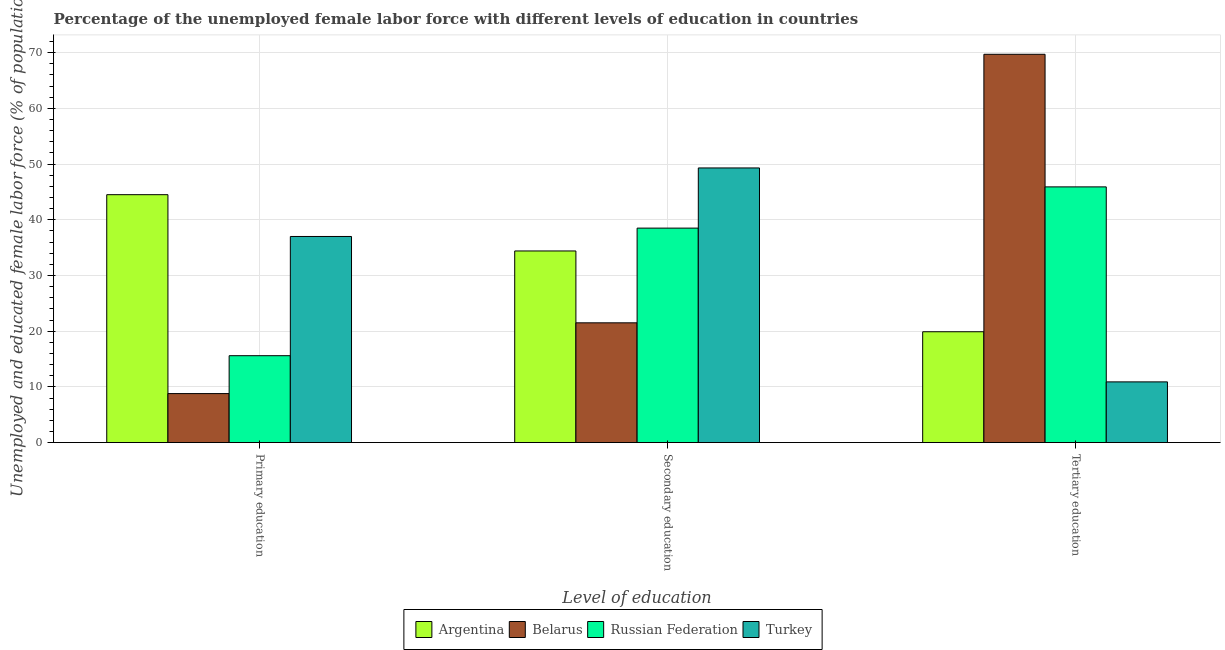What is the label of the 3rd group of bars from the left?
Provide a short and direct response. Tertiary education. What is the percentage of female labor force who received tertiary education in Russian Federation?
Your answer should be very brief. 45.9. Across all countries, what is the maximum percentage of female labor force who received primary education?
Provide a succinct answer. 44.5. Across all countries, what is the minimum percentage of female labor force who received tertiary education?
Your answer should be compact. 10.9. In which country was the percentage of female labor force who received secondary education minimum?
Keep it short and to the point. Belarus. What is the total percentage of female labor force who received primary education in the graph?
Your answer should be compact. 105.9. What is the difference between the percentage of female labor force who received primary education in Turkey and that in Argentina?
Give a very brief answer. -7.5. What is the difference between the percentage of female labor force who received primary education in Turkey and the percentage of female labor force who received secondary education in Argentina?
Make the answer very short. 2.6. What is the average percentage of female labor force who received secondary education per country?
Provide a short and direct response. 35.93. What is the difference between the percentage of female labor force who received primary education and percentage of female labor force who received secondary education in Russian Federation?
Offer a terse response. -22.9. In how many countries, is the percentage of female labor force who received primary education greater than 10 %?
Your response must be concise. 3. What is the ratio of the percentage of female labor force who received primary education in Belarus to that in Russian Federation?
Provide a short and direct response. 0.56. What is the difference between the highest and the second highest percentage of female labor force who received secondary education?
Ensure brevity in your answer.  10.8. What is the difference between the highest and the lowest percentage of female labor force who received primary education?
Make the answer very short. 35.7. Is the sum of the percentage of female labor force who received tertiary education in Turkey and Russian Federation greater than the maximum percentage of female labor force who received primary education across all countries?
Make the answer very short. Yes. What does the 4th bar from the left in Secondary education represents?
Make the answer very short. Turkey. What does the 3rd bar from the right in Primary education represents?
Offer a terse response. Belarus. Is it the case that in every country, the sum of the percentage of female labor force who received primary education and percentage of female labor force who received secondary education is greater than the percentage of female labor force who received tertiary education?
Offer a terse response. No. How many bars are there?
Provide a short and direct response. 12. Are all the bars in the graph horizontal?
Keep it short and to the point. No. What is the difference between two consecutive major ticks on the Y-axis?
Provide a succinct answer. 10. Does the graph contain grids?
Give a very brief answer. Yes. Where does the legend appear in the graph?
Provide a short and direct response. Bottom center. How many legend labels are there?
Give a very brief answer. 4. What is the title of the graph?
Your response must be concise. Percentage of the unemployed female labor force with different levels of education in countries. What is the label or title of the X-axis?
Keep it short and to the point. Level of education. What is the label or title of the Y-axis?
Give a very brief answer. Unemployed and educated female labor force (% of population). What is the Unemployed and educated female labor force (% of population) in Argentina in Primary education?
Your answer should be very brief. 44.5. What is the Unemployed and educated female labor force (% of population) in Belarus in Primary education?
Offer a terse response. 8.8. What is the Unemployed and educated female labor force (% of population) in Russian Federation in Primary education?
Provide a succinct answer. 15.6. What is the Unemployed and educated female labor force (% of population) in Turkey in Primary education?
Your answer should be very brief. 37. What is the Unemployed and educated female labor force (% of population) of Argentina in Secondary education?
Your answer should be compact. 34.4. What is the Unemployed and educated female labor force (% of population) in Belarus in Secondary education?
Keep it short and to the point. 21.5. What is the Unemployed and educated female labor force (% of population) of Russian Federation in Secondary education?
Make the answer very short. 38.5. What is the Unemployed and educated female labor force (% of population) of Turkey in Secondary education?
Your response must be concise. 49.3. What is the Unemployed and educated female labor force (% of population) of Argentina in Tertiary education?
Your answer should be compact. 19.9. What is the Unemployed and educated female labor force (% of population) of Belarus in Tertiary education?
Provide a short and direct response. 69.7. What is the Unemployed and educated female labor force (% of population) in Russian Federation in Tertiary education?
Provide a succinct answer. 45.9. What is the Unemployed and educated female labor force (% of population) in Turkey in Tertiary education?
Offer a terse response. 10.9. Across all Level of education, what is the maximum Unemployed and educated female labor force (% of population) in Argentina?
Your answer should be very brief. 44.5. Across all Level of education, what is the maximum Unemployed and educated female labor force (% of population) of Belarus?
Provide a succinct answer. 69.7. Across all Level of education, what is the maximum Unemployed and educated female labor force (% of population) of Russian Federation?
Give a very brief answer. 45.9. Across all Level of education, what is the maximum Unemployed and educated female labor force (% of population) of Turkey?
Make the answer very short. 49.3. Across all Level of education, what is the minimum Unemployed and educated female labor force (% of population) of Argentina?
Give a very brief answer. 19.9. Across all Level of education, what is the minimum Unemployed and educated female labor force (% of population) of Belarus?
Ensure brevity in your answer.  8.8. Across all Level of education, what is the minimum Unemployed and educated female labor force (% of population) in Russian Federation?
Give a very brief answer. 15.6. Across all Level of education, what is the minimum Unemployed and educated female labor force (% of population) of Turkey?
Provide a succinct answer. 10.9. What is the total Unemployed and educated female labor force (% of population) in Argentina in the graph?
Ensure brevity in your answer.  98.8. What is the total Unemployed and educated female labor force (% of population) in Turkey in the graph?
Make the answer very short. 97.2. What is the difference between the Unemployed and educated female labor force (% of population) of Argentina in Primary education and that in Secondary education?
Offer a terse response. 10.1. What is the difference between the Unemployed and educated female labor force (% of population) in Belarus in Primary education and that in Secondary education?
Provide a succinct answer. -12.7. What is the difference between the Unemployed and educated female labor force (% of population) of Russian Federation in Primary education and that in Secondary education?
Give a very brief answer. -22.9. What is the difference between the Unemployed and educated female labor force (% of population) of Argentina in Primary education and that in Tertiary education?
Ensure brevity in your answer.  24.6. What is the difference between the Unemployed and educated female labor force (% of population) of Belarus in Primary education and that in Tertiary education?
Offer a terse response. -60.9. What is the difference between the Unemployed and educated female labor force (% of population) of Russian Federation in Primary education and that in Tertiary education?
Keep it short and to the point. -30.3. What is the difference between the Unemployed and educated female labor force (% of population) in Turkey in Primary education and that in Tertiary education?
Your response must be concise. 26.1. What is the difference between the Unemployed and educated female labor force (% of population) in Belarus in Secondary education and that in Tertiary education?
Provide a succinct answer. -48.2. What is the difference between the Unemployed and educated female labor force (% of population) in Russian Federation in Secondary education and that in Tertiary education?
Offer a very short reply. -7.4. What is the difference between the Unemployed and educated female labor force (% of population) in Turkey in Secondary education and that in Tertiary education?
Offer a very short reply. 38.4. What is the difference between the Unemployed and educated female labor force (% of population) in Argentina in Primary education and the Unemployed and educated female labor force (% of population) in Belarus in Secondary education?
Offer a terse response. 23. What is the difference between the Unemployed and educated female labor force (% of population) of Belarus in Primary education and the Unemployed and educated female labor force (% of population) of Russian Federation in Secondary education?
Make the answer very short. -29.7. What is the difference between the Unemployed and educated female labor force (% of population) of Belarus in Primary education and the Unemployed and educated female labor force (% of population) of Turkey in Secondary education?
Offer a very short reply. -40.5. What is the difference between the Unemployed and educated female labor force (% of population) in Russian Federation in Primary education and the Unemployed and educated female labor force (% of population) in Turkey in Secondary education?
Your response must be concise. -33.7. What is the difference between the Unemployed and educated female labor force (% of population) in Argentina in Primary education and the Unemployed and educated female labor force (% of population) in Belarus in Tertiary education?
Your answer should be very brief. -25.2. What is the difference between the Unemployed and educated female labor force (% of population) in Argentina in Primary education and the Unemployed and educated female labor force (% of population) in Russian Federation in Tertiary education?
Make the answer very short. -1.4. What is the difference between the Unemployed and educated female labor force (% of population) of Argentina in Primary education and the Unemployed and educated female labor force (% of population) of Turkey in Tertiary education?
Make the answer very short. 33.6. What is the difference between the Unemployed and educated female labor force (% of population) in Belarus in Primary education and the Unemployed and educated female labor force (% of population) in Russian Federation in Tertiary education?
Ensure brevity in your answer.  -37.1. What is the difference between the Unemployed and educated female labor force (% of population) of Russian Federation in Primary education and the Unemployed and educated female labor force (% of population) of Turkey in Tertiary education?
Provide a short and direct response. 4.7. What is the difference between the Unemployed and educated female labor force (% of population) of Argentina in Secondary education and the Unemployed and educated female labor force (% of population) of Belarus in Tertiary education?
Offer a terse response. -35.3. What is the difference between the Unemployed and educated female labor force (% of population) in Belarus in Secondary education and the Unemployed and educated female labor force (% of population) in Russian Federation in Tertiary education?
Provide a short and direct response. -24.4. What is the difference between the Unemployed and educated female labor force (% of population) in Russian Federation in Secondary education and the Unemployed and educated female labor force (% of population) in Turkey in Tertiary education?
Offer a terse response. 27.6. What is the average Unemployed and educated female labor force (% of population) of Argentina per Level of education?
Provide a succinct answer. 32.93. What is the average Unemployed and educated female labor force (% of population) in Belarus per Level of education?
Your answer should be compact. 33.33. What is the average Unemployed and educated female labor force (% of population) in Russian Federation per Level of education?
Give a very brief answer. 33.33. What is the average Unemployed and educated female labor force (% of population) in Turkey per Level of education?
Your answer should be very brief. 32.4. What is the difference between the Unemployed and educated female labor force (% of population) of Argentina and Unemployed and educated female labor force (% of population) of Belarus in Primary education?
Give a very brief answer. 35.7. What is the difference between the Unemployed and educated female labor force (% of population) of Argentina and Unemployed and educated female labor force (% of population) of Russian Federation in Primary education?
Provide a short and direct response. 28.9. What is the difference between the Unemployed and educated female labor force (% of population) in Belarus and Unemployed and educated female labor force (% of population) in Russian Federation in Primary education?
Make the answer very short. -6.8. What is the difference between the Unemployed and educated female labor force (% of population) in Belarus and Unemployed and educated female labor force (% of population) in Turkey in Primary education?
Make the answer very short. -28.2. What is the difference between the Unemployed and educated female labor force (% of population) in Russian Federation and Unemployed and educated female labor force (% of population) in Turkey in Primary education?
Ensure brevity in your answer.  -21.4. What is the difference between the Unemployed and educated female labor force (% of population) in Argentina and Unemployed and educated female labor force (% of population) in Russian Federation in Secondary education?
Ensure brevity in your answer.  -4.1. What is the difference between the Unemployed and educated female labor force (% of population) in Argentina and Unemployed and educated female labor force (% of population) in Turkey in Secondary education?
Keep it short and to the point. -14.9. What is the difference between the Unemployed and educated female labor force (% of population) of Belarus and Unemployed and educated female labor force (% of population) of Russian Federation in Secondary education?
Make the answer very short. -17. What is the difference between the Unemployed and educated female labor force (% of population) of Belarus and Unemployed and educated female labor force (% of population) of Turkey in Secondary education?
Provide a succinct answer. -27.8. What is the difference between the Unemployed and educated female labor force (% of population) of Russian Federation and Unemployed and educated female labor force (% of population) of Turkey in Secondary education?
Give a very brief answer. -10.8. What is the difference between the Unemployed and educated female labor force (% of population) of Argentina and Unemployed and educated female labor force (% of population) of Belarus in Tertiary education?
Keep it short and to the point. -49.8. What is the difference between the Unemployed and educated female labor force (% of population) in Argentina and Unemployed and educated female labor force (% of population) in Turkey in Tertiary education?
Offer a terse response. 9. What is the difference between the Unemployed and educated female labor force (% of population) in Belarus and Unemployed and educated female labor force (% of population) in Russian Federation in Tertiary education?
Make the answer very short. 23.8. What is the difference between the Unemployed and educated female labor force (% of population) in Belarus and Unemployed and educated female labor force (% of population) in Turkey in Tertiary education?
Ensure brevity in your answer.  58.8. What is the ratio of the Unemployed and educated female labor force (% of population) of Argentina in Primary education to that in Secondary education?
Your answer should be very brief. 1.29. What is the ratio of the Unemployed and educated female labor force (% of population) of Belarus in Primary education to that in Secondary education?
Your answer should be very brief. 0.41. What is the ratio of the Unemployed and educated female labor force (% of population) of Russian Federation in Primary education to that in Secondary education?
Offer a terse response. 0.41. What is the ratio of the Unemployed and educated female labor force (% of population) in Turkey in Primary education to that in Secondary education?
Your answer should be very brief. 0.75. What is the ratio of the Unemployed and educated female labor force (% of population) of Argentina in Primary education to that in Tertiary education?
Offer a terse response. 2.24. What is the ratio of the Unemployed and educated female labor force (% of population) in Belarus in Primary education to that in Tertiary education?
Offer a terse response. 0.13. What is the ratio of the Unemployed and educated female labor force (% of population) in Russian Federation in Primary education to that in Tertiary education?
Offer a very short reply. 0.34. What is the ratio of the Unemployed and educated female labor force (% of population) of Turkey in Primary education to that in Tertiary education?
Give a very brief answer. 3.39. What is the ratio of the Unemployed and educated female labor force (% of population) in Argentina in Secondary education to that in Tertiary education?
Make the answer very short. 1.73. What is the ratio of the Unemployed and educated female labor force (% of population) in Belarus in Secondary education to that in Tertiary education?
Provide a short and direct response. 0.31. What is the ratio of the Unemployed and educated female labor force (% of population) in Russian Federation in Secondary education to that in Tertiary education?
Your answer should be very brief. 0.84. What is the ratio of the Unemployed and educated female labor force (% of population) of Turkey in Secondary education to that in Tertiary education?
Provide a succinct answer. 4.52. What is the difference between the highest and the second highest Unemployed and educated female labor force (% of population) in Argentina?
Give a very brief answer. 10.1. What is the difference between the highest and the second highest Unemployed and educated female labor force (% of population) in Belarus?
Give a very brief answer. 48.2. What is the difference between the highest and the lowest Unemployed and educated female labor force (% of population) in Argentina?
Ensure brevity in your answer.  24.6. What is the difference between the highest and the lowest Unemployed and educated female labor force (% of population) of Belarus?
Keep it short and to the point. 60.9. What is the difference between the highest and the lowest Unemployed and educated female labor force (% of population) in Russian Federation?
Offer a very short reply. 30.3. What is the difference between the highest and the lowest Unemployed and educated female labor force (% of population) in Turkey?
Provide a succinct answer. 38.4. 